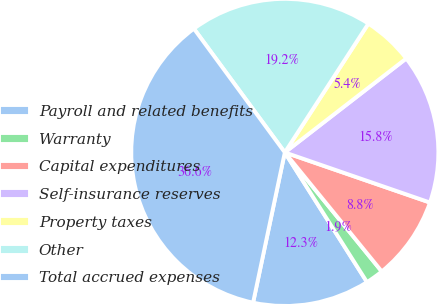<chart> <loc_0><loc_0><loc_500><loc_500><pie_chart><fcel>Payroll and related benefits<fcel>Warranty<fcel>Capital expenditures<fcel>Self-insurance reserves<fcel>Property taxes<fcel>Other<fcel>Total accrued expenses<nl><fcel>12.3%<fcel>1.89%<fcel>8.83%<fcel>15.77%<fcel>5.36%<fcel>19.24%<fcel>36.6%<nl></chart> 